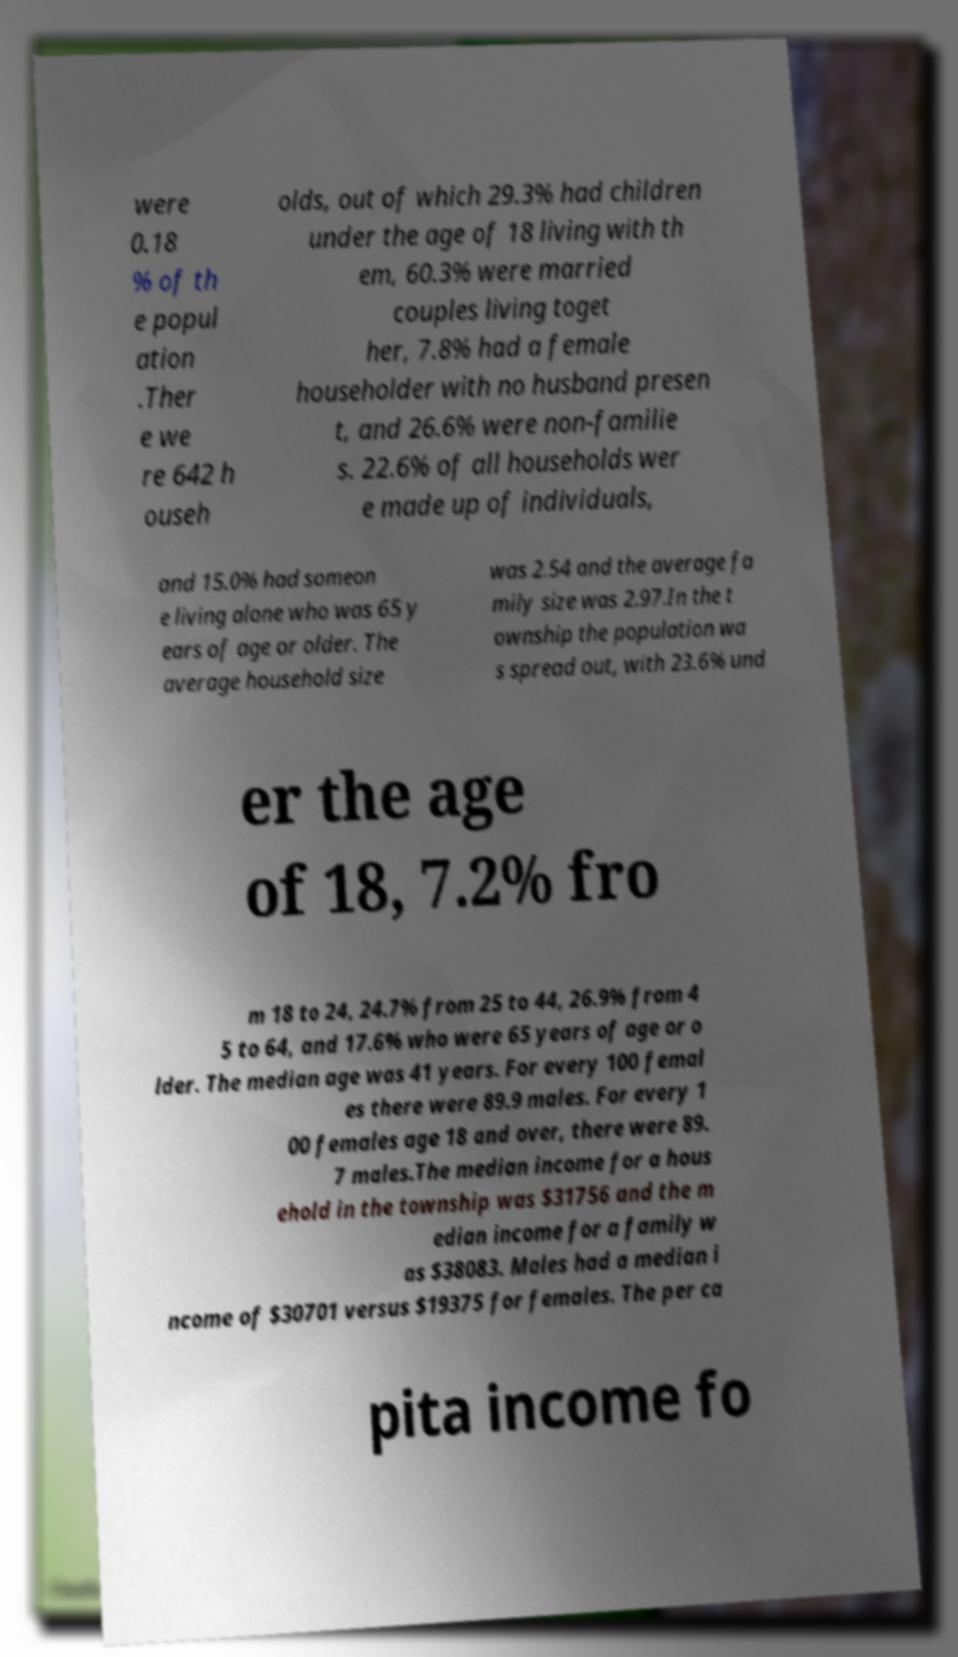Please read and relay the text visible in this image. What does it say? were 0.18 % of th e popul ation .Ther e we re 642 h ouseh olds, out of which 29.3% had children under the age of 18 living with th em, 60.3% were married couples living toget her, 7.8% had a female householder with no husband presen t, and 26.6% were non-familie s. 22.6% of all households wer e made up of individuals, and 15.0% had someon e living alone who was 65 y ears of age or older. The average household size was 2.54 and the average fa mily size was 2.97.In the t ownship the population wa s spread out, with 23.6% und er the age of 18, 7.2% fro m 18 to 24, 24.7% from 25 to 44, 26.9% from 4 5 to 64, and 17.6% who were 65 years of age or o lder. The median age was 41 years. For every 100 femal es there were 89.9 males. For every 1 00 females age 18 and over, there were 89. 7 males.The median income for a hous ehold in the township was $31756 and the m edian income for a family w as $38083. Males had a median i ncome of $30701 versus $19375 for females. The per ca pita income fo 